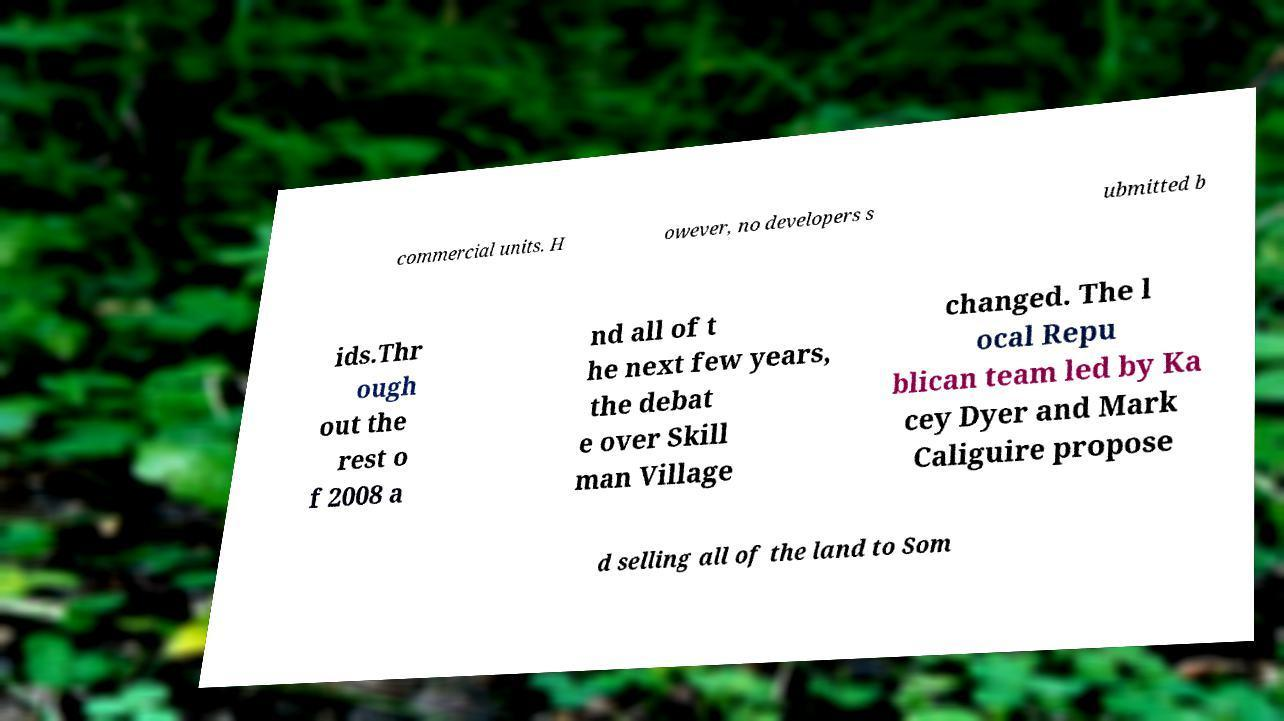I need the written content from this picture converted into text. Can you do that? commercial units. H owever, no developers s ubmitted b ids.Thr ough out the rest o f 2008 a nd all of t he next few years, the debat e over Skill man Village changed. The l ocal Repu blican team led by Ka cey Dyer and Mark Caliguire propose d selling all of the land to Som 